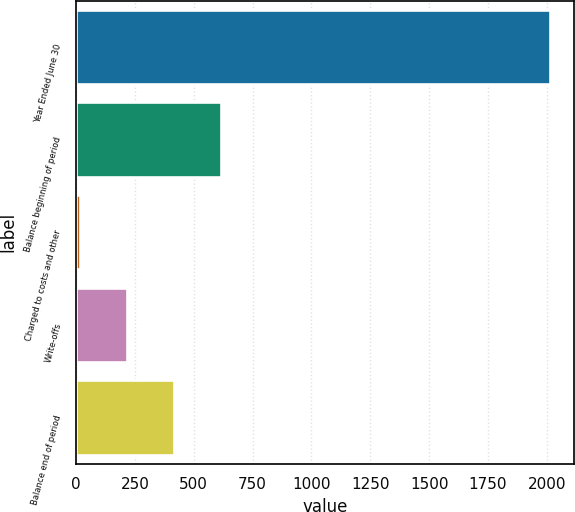Convert chart. <chart><loc_0><loc_0><loc_500><loc_500><bar_chart><fcel>Year Ended June 30<fcel>Balance beginning of period<fcel>Charged to costs and other<fcel>Write-offs<fcel>Balance end of period<nl><fcel>2014<fcel>615.4<fcel>16<fcel>215.8<fcel>415.6<nl></chart> 